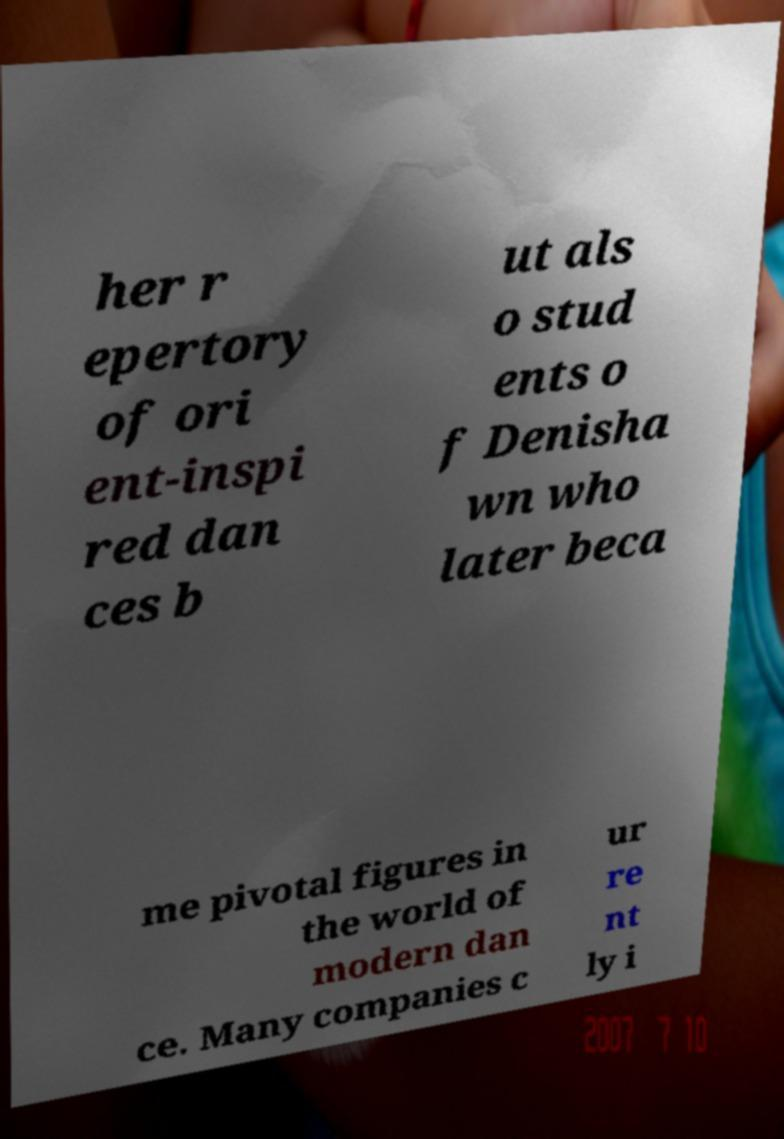Please identify and transcribe the text found in this image. her r epertory of ori ent-inspi red dan ces b ut als o stud ents o f Denisha wn who later beca me pivotal figures in the world of modern dan ce. Many companies c ur re nt ly i 